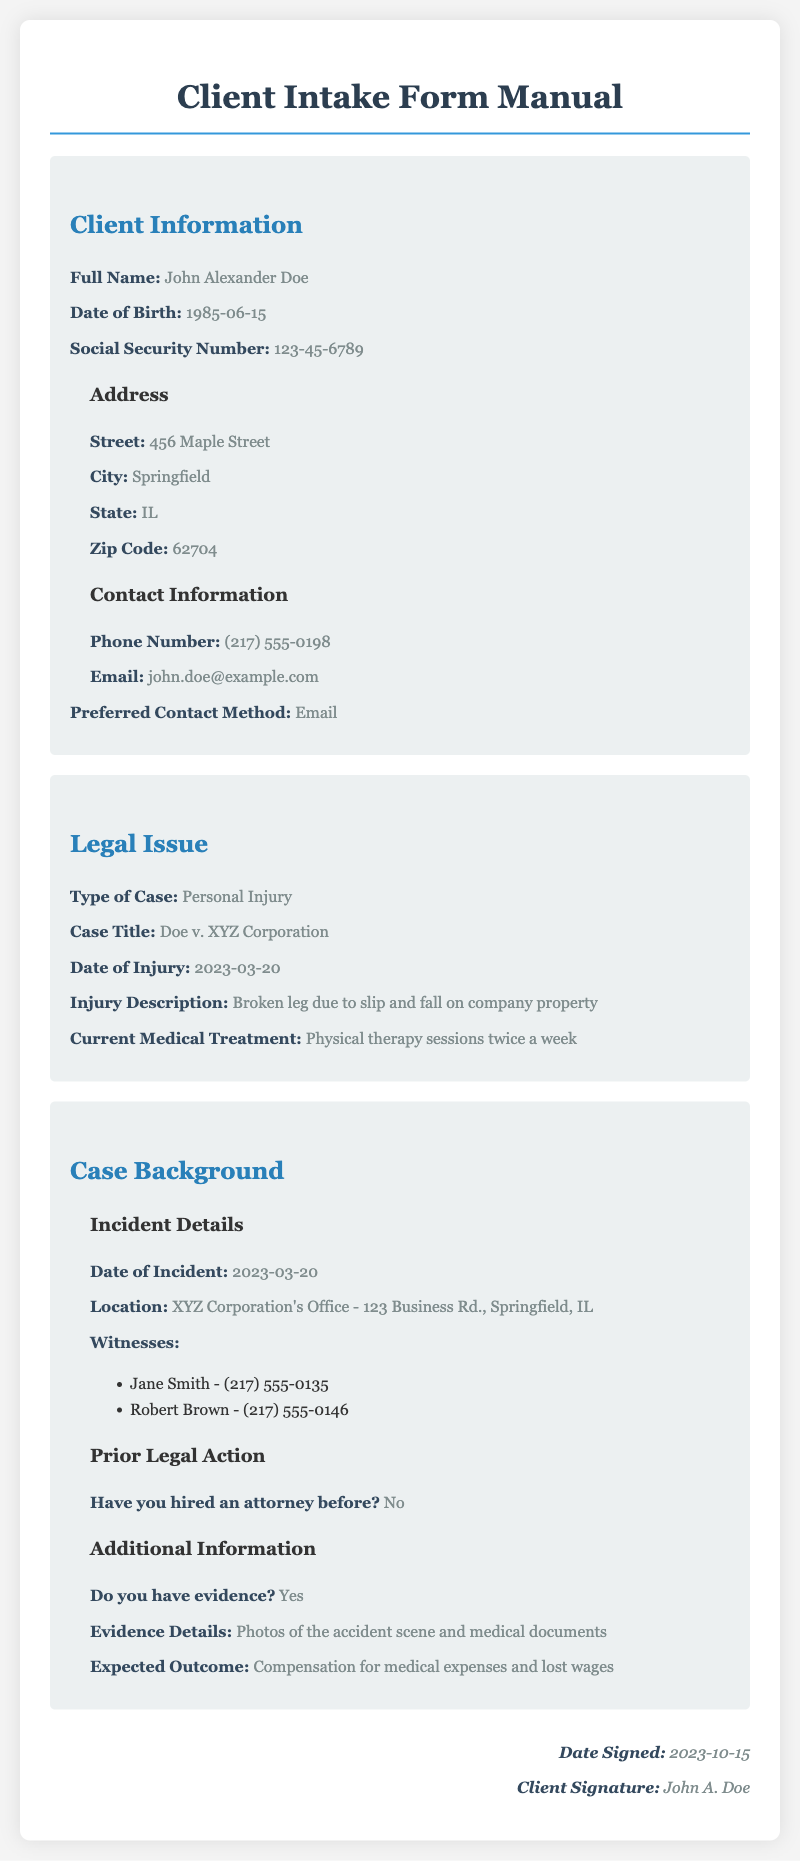What is the client's full name? The client's name is specifically stated in the Client Information section.
Answer: John Alexander Doe What is the client's date of birth? The date of birth is provided in the Client Information section under Personal Information.
Answer: 1985-06-15 What type of case is being discussed? The specific type of case is defined in the Legal Issue section of the document.
Answer: Personal Injury What was the date of the injury? This information is detailed in the Legal Issue section and pertains to when the injury occurred.
Answer: 2023-03-20 Who are the witnesses listed? The witnesses' names and their contact numbers are listed under the Incident Details subsection in the Case Background section.
Answer: Jane Smith and Robert Brown What is the expected outcome desired by the client? The expected outcome is stated in the Additional Information subsection of the Case Background section.
Answer: Compensation for medical expenses and lost wages Did the client hire an attorney before? This information can be found in the Prior Legal Action subsection of the Case Background section.
Answer: No What is the client's preferred contact method? The preferred contact method is stated in the Client Information section.
Answer: Email What is the client's email address? The email address is included under the Contact Information subsection in the Client Information section.
Answer: john.doe@example.com 